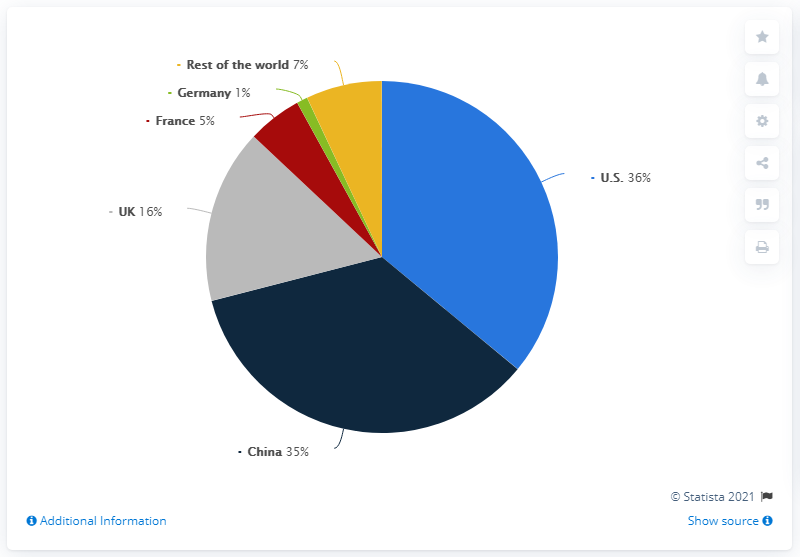List a handful of essential elements in this visual. The total revenue from the post-war and contemporary art auction in China and the U.K. in 2020 was $51 million. The revenue from the Post-War and Contemporary art auction in China in 2020 was 35 million. The post-war and contemporary art market in 2020 was led by China, which was the second-leading market in terms of overall sales. 